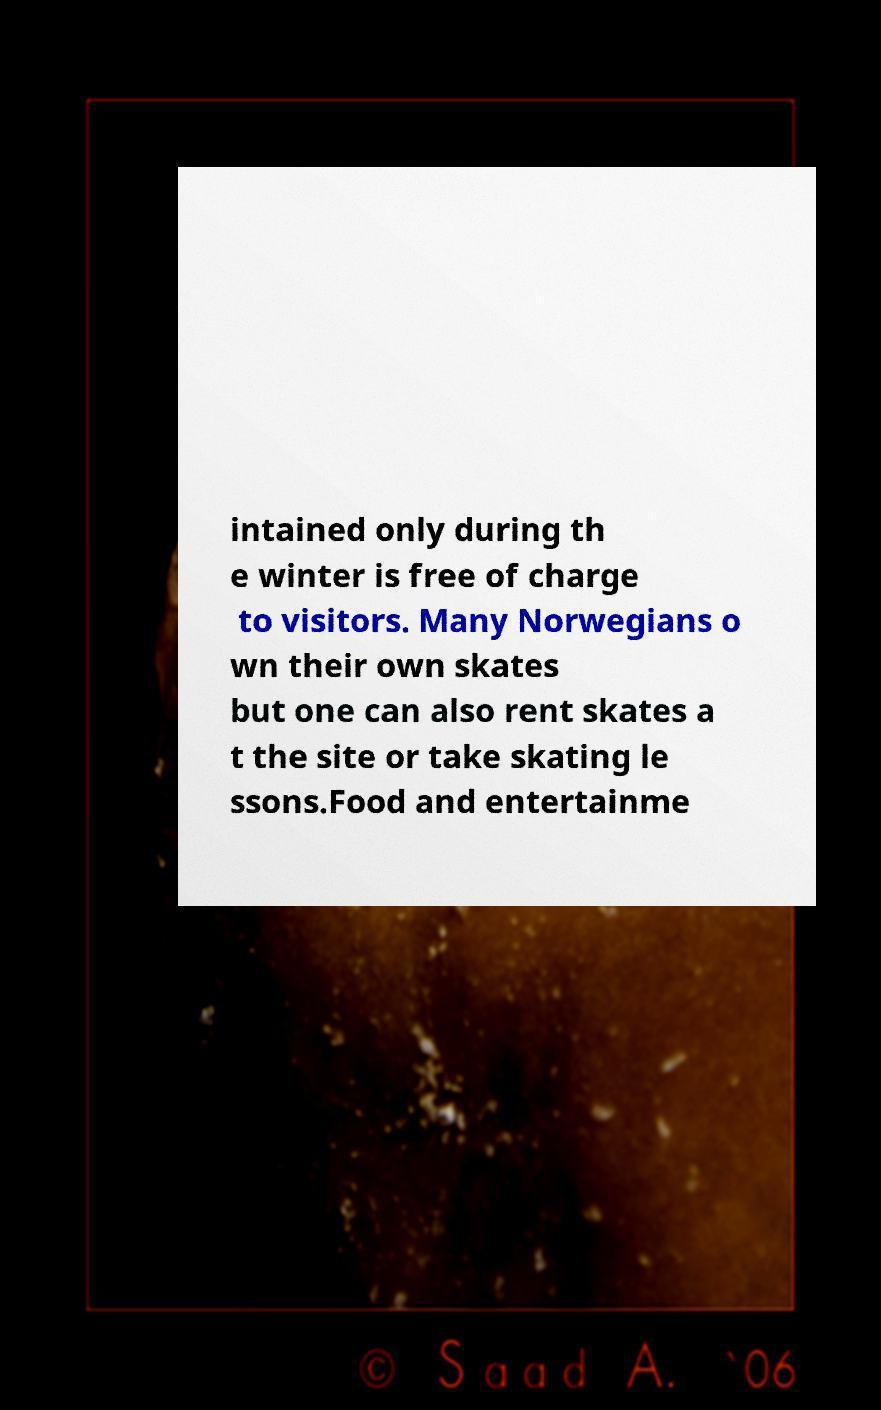What messages or text are displayed in this image? I need them in a readable, typed format. intained only during th e winter is free of charge to visitors. Many Norwegians o wn their own skates but one can also rent skates a t the site or take skating le ssons.Food and entertainme 